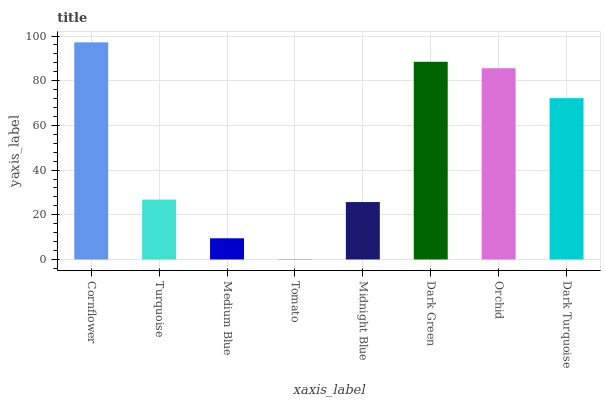Is Turquoise the minimum?
Answer yes or no. No. Is Turquoise the maximum?
Answer yes or no. No. Is Cornflower greater than Turquoise?
Answer yes or no. Yes. Is Turquoise less than Cornflower?
Answer yes or no. Yes. Is Turquoise greater than Cornflower?
Answer yes or no. No. Is Cornflower less than Turquoise?
Answer yes or no. No. Is Dark Turquoise the high median?
Answer yes or no. Yes. Is Turquoise the low median?
Answer yes or no. Yes. Is Medium Blue the high median?
Answer yes or no. No. Is Tomato the low median?
Answer yes or no. No. 